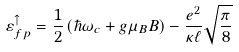Convert formula to latex. <formula><loc_0><loc_0><loc_500><loc_500>\varepsilon _ { f p } ^ { \uparrow } = \frac { 1 } { 2 } \left ( \hbar { \omega } _ { c } + g \mu _ { B } B \right ) - \frac { e ^ { 2 } } { \kappa \ell } \sqrt { \frac { \pi } { 8 } }</formula> 